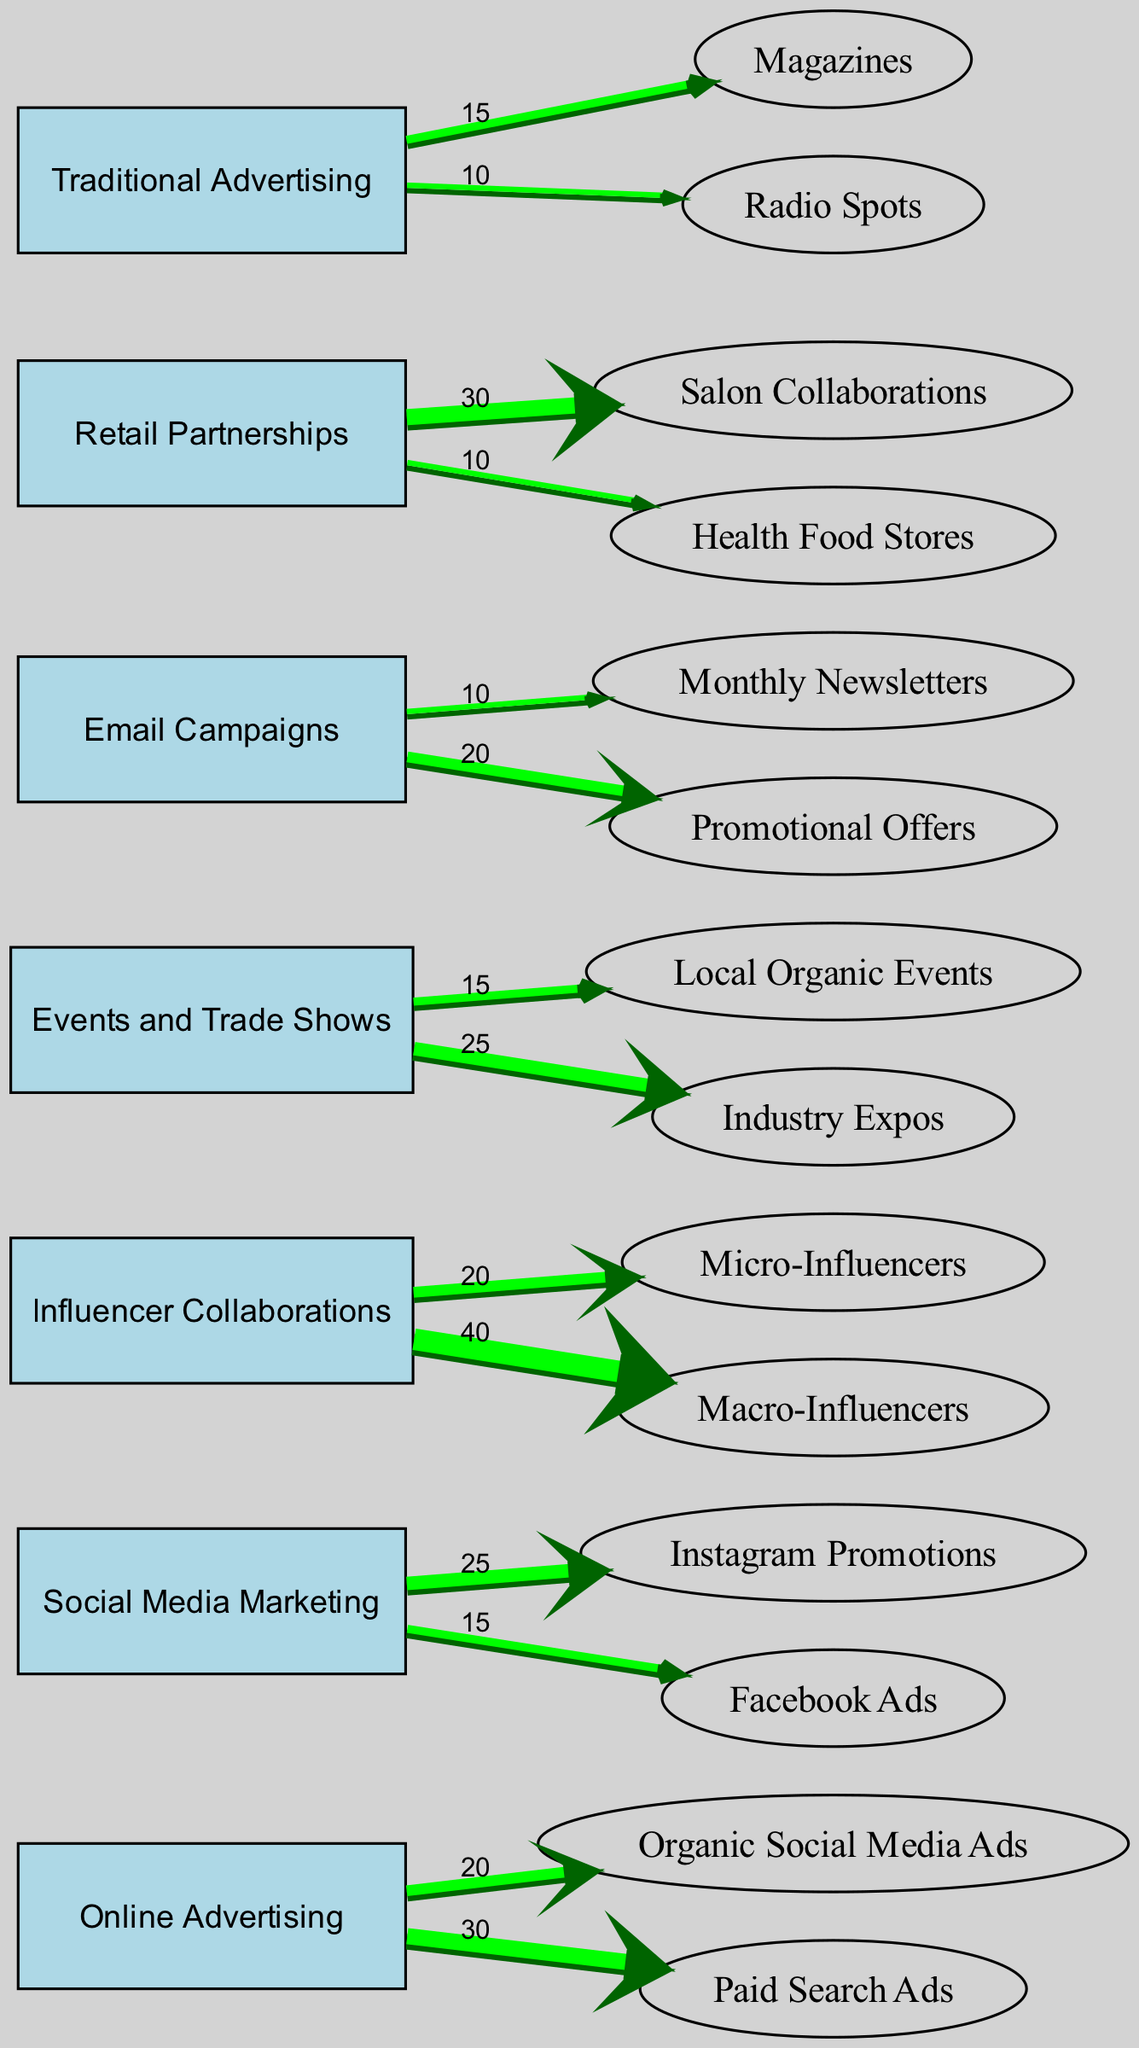What is the total expenditure for Influencer Collaborations? From the diagram, the values for Influencer Collaborations are 20 for Micro-Influencers and 40 for Macro-Influencers. Summing these values gives 20 + 40 = 60.
Answer: 60 Which marketing channel has the highest expenditure? Analyzing the diagram, the highest individual expenditure is 40 for Macro-Influencers under Influencer Collaborations, which is greater than the highest expenditure of 30 for Paid Search Ads. Thus, the overall marketing channel with the highest single expenditure is Influencer Collaborations.
Answer: Influencer Collaborations How many nodes are there in the diagram? By counting the individual entries in the nodes section of the diagram, we find there are 7 distinct nodes listed: Online Advertising, Social Media Marketing, Influencer Collaborations, Events and Trade Shows, Email Campaigns, Retail Partnerships, and Traditional Advertising.
Answer: 7 What is the expenditure for Email Campaigns specifically for Promotional Offers? The diagram indicates that the expenditure for Email Campaigns directed toward Promotional Offers is explicitly labeled as 20.
Answer: 20 How much is spent on Local Organic Events compared to Industry Expos? From the diagram, Local Organic Events has an expenditure of 15, while Industry Expos has an expenditure of 25. Comparing these values, we find that Industry Expos has higher spending. The difference is 25 - 15 = 10.
Answer: 10 What is the total expenditure flowing out from Online Advertising? The diagram shows two expenditures coming from Online Advertising: 20 for Organic Social Media Ads and 30 for Paid Search Ads. Adding these expenditures gives 20 + 30 = 50.
Answer: 50 Which platform receives the most significant expenditure from Social Media Marketing? Analyzing the expenditures from Social Media Marketing, we see that Instagram Promotions receives 25, while Facebook Ads receives 15. Consequently, the greater expenditure is directed toward Instagram Promotions.
Answer: Instagram Promotions What is the total expenditure for Traditional Advertising? Traditional Advertising has two child nodes: Magazines (15) and Radio Spots (10). Summing these gives a total expenditure of 15 + 10 = 25.
Answer: 25 What percentage of the total marketing budget is allocated to Retail Partnerships? Retail Partnerships has expenditures of 30 for Salon Collaborations and 10 for Health Food Stores, leading to an overall total of 40. To find the percentage, sum all expenditures from the diagram, which is 60 (Influencers) + 50 (Online Ads) + 40 (Retail) + 25 (Events) + 30 (Email) + 25 (Traditional) = 230. Thus, (40/230) * 100 ≈ 17.39%.
Answer: 17.39% 